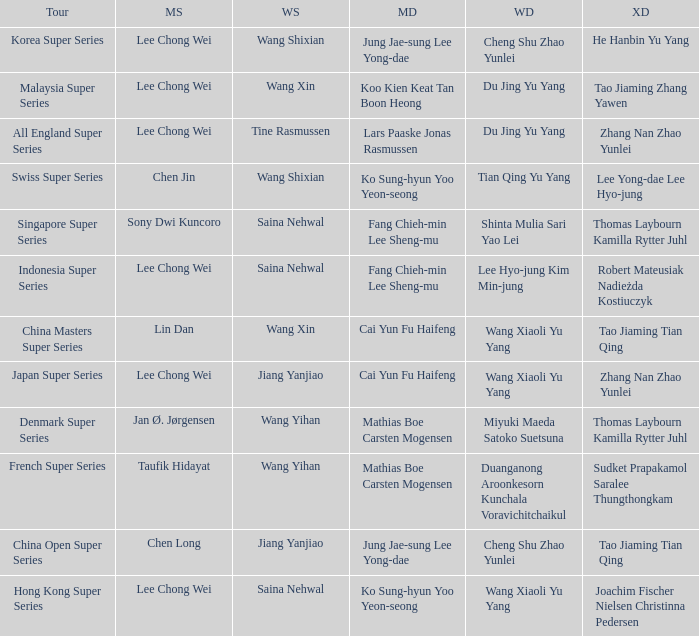Who were the womens doubles when the mixed doubles were zhang nan zhao yunlei on the tour all england super series? Du Jing Yu Yang. 